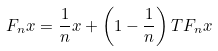<formula> <loc_0><loc_0><loc_500><loc_500>F _ { n } x = \frac { 1 } { n } x + \left ( 1 - \frac { 1 } { n } \right ) T F _ { n } x</formula> 